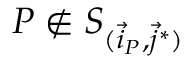Convert formula to latex. <formula><loc_0><loc_0><loc_500><loc_500>P \notin S _ { ( \vec { i } _ { P } , \vec { j } ^ { * } ) }</formula> 